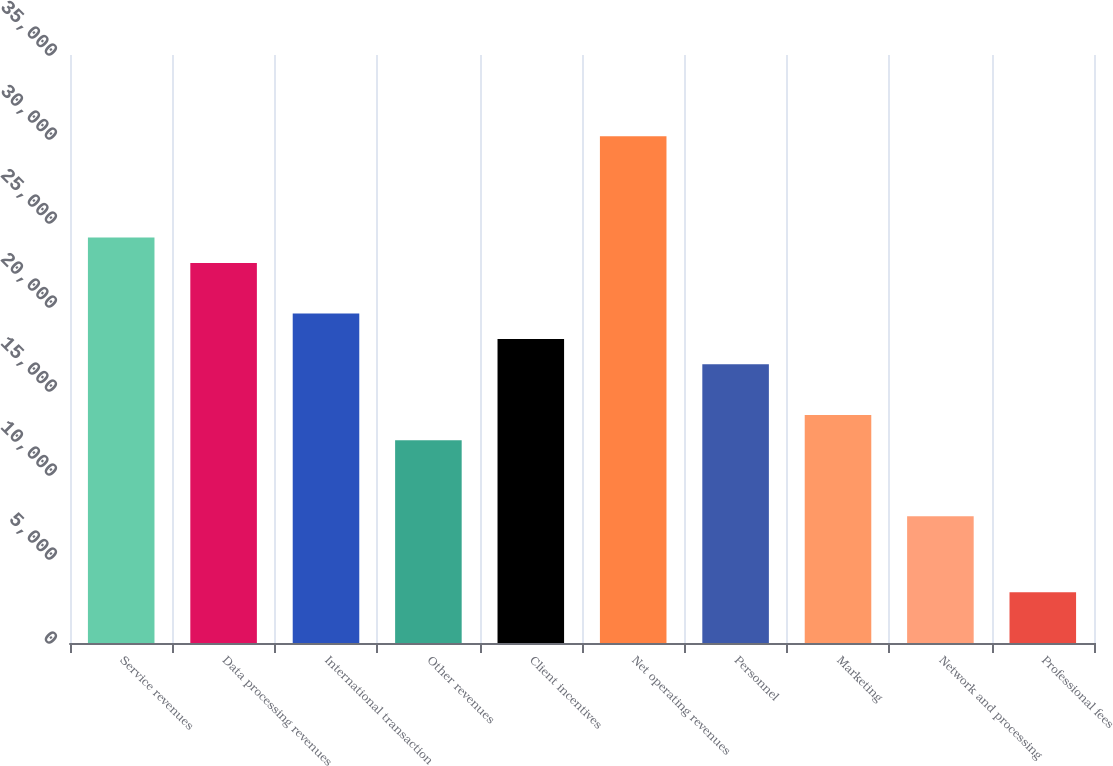<chart> <loc_0><loc_0><loc_500><loc_500><bar_chart><fcel>Service revenues<fcel>Data processing revenues<fcel>International transaction<fcel>Other revenues<fcel>Client incentives<fcel>Net operating revenues<fcel>Personnel<fcel>Marketing<fcel>Network and processing<fcel>Professional fees<nl><fcel>24130<fcel>22622<fcel>19606<fcel>12066<fcel>18098<fcel>30162<fcel>16590<fcel>13574<fcel>7542<fcel>3018<nl></chart> 